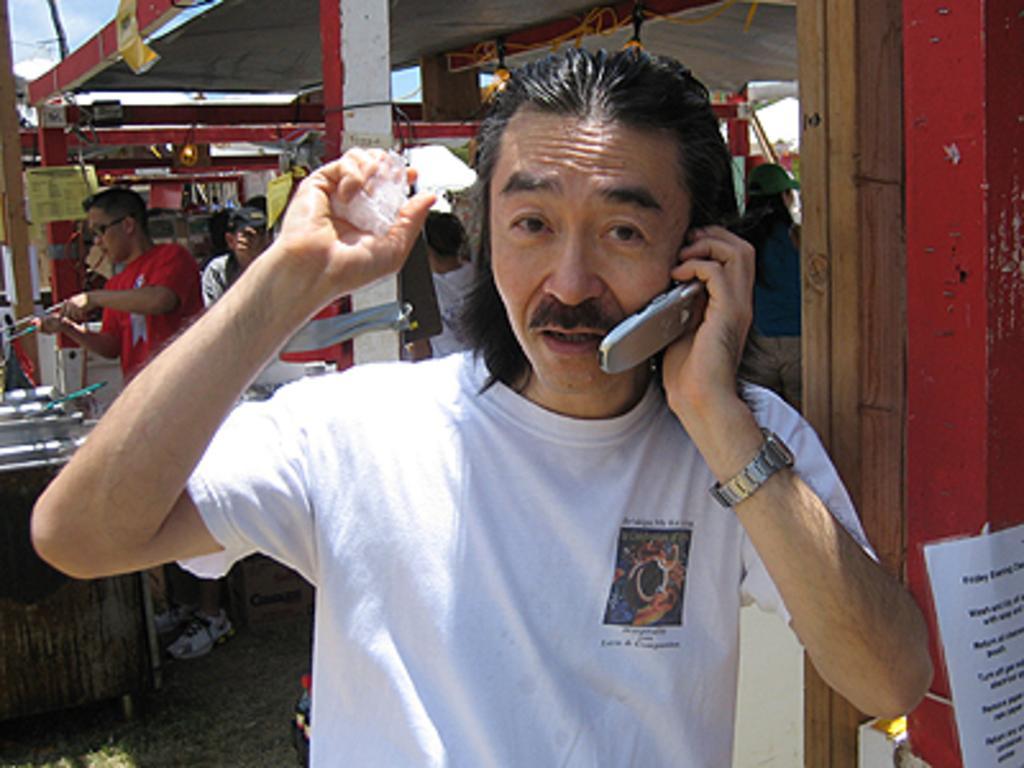Could you give a brief overview of what you see in this image? In this picture there is a person standing and holding the cellphone and object. At the back there are group of people standing and there is a person with red t-shirt is standing and holding the object and there are objects on the table and there are boards on the wall. At the top there is sky. At the bottom there is grass. On the right side of the image there is a paper on the wall and there is text on the paper. 